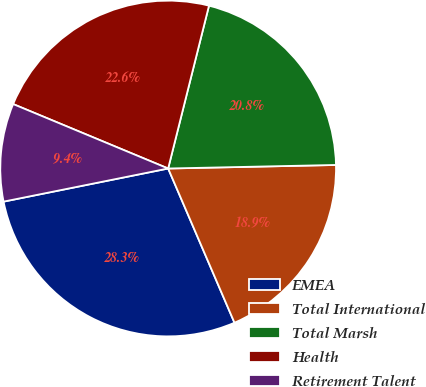<chart> <loc_0><loc_0><loc_500><loc_500><pie_chart><fcel>EMEA<fcel>Total International<fcel>Total Marsh<fcel>Health<fcel>Retirement Talent<nl><fcel>28.3%<fcel>18.87%<fcel>20.75%<fcel>22.64%<fcel>9.43%<nl></chart> 